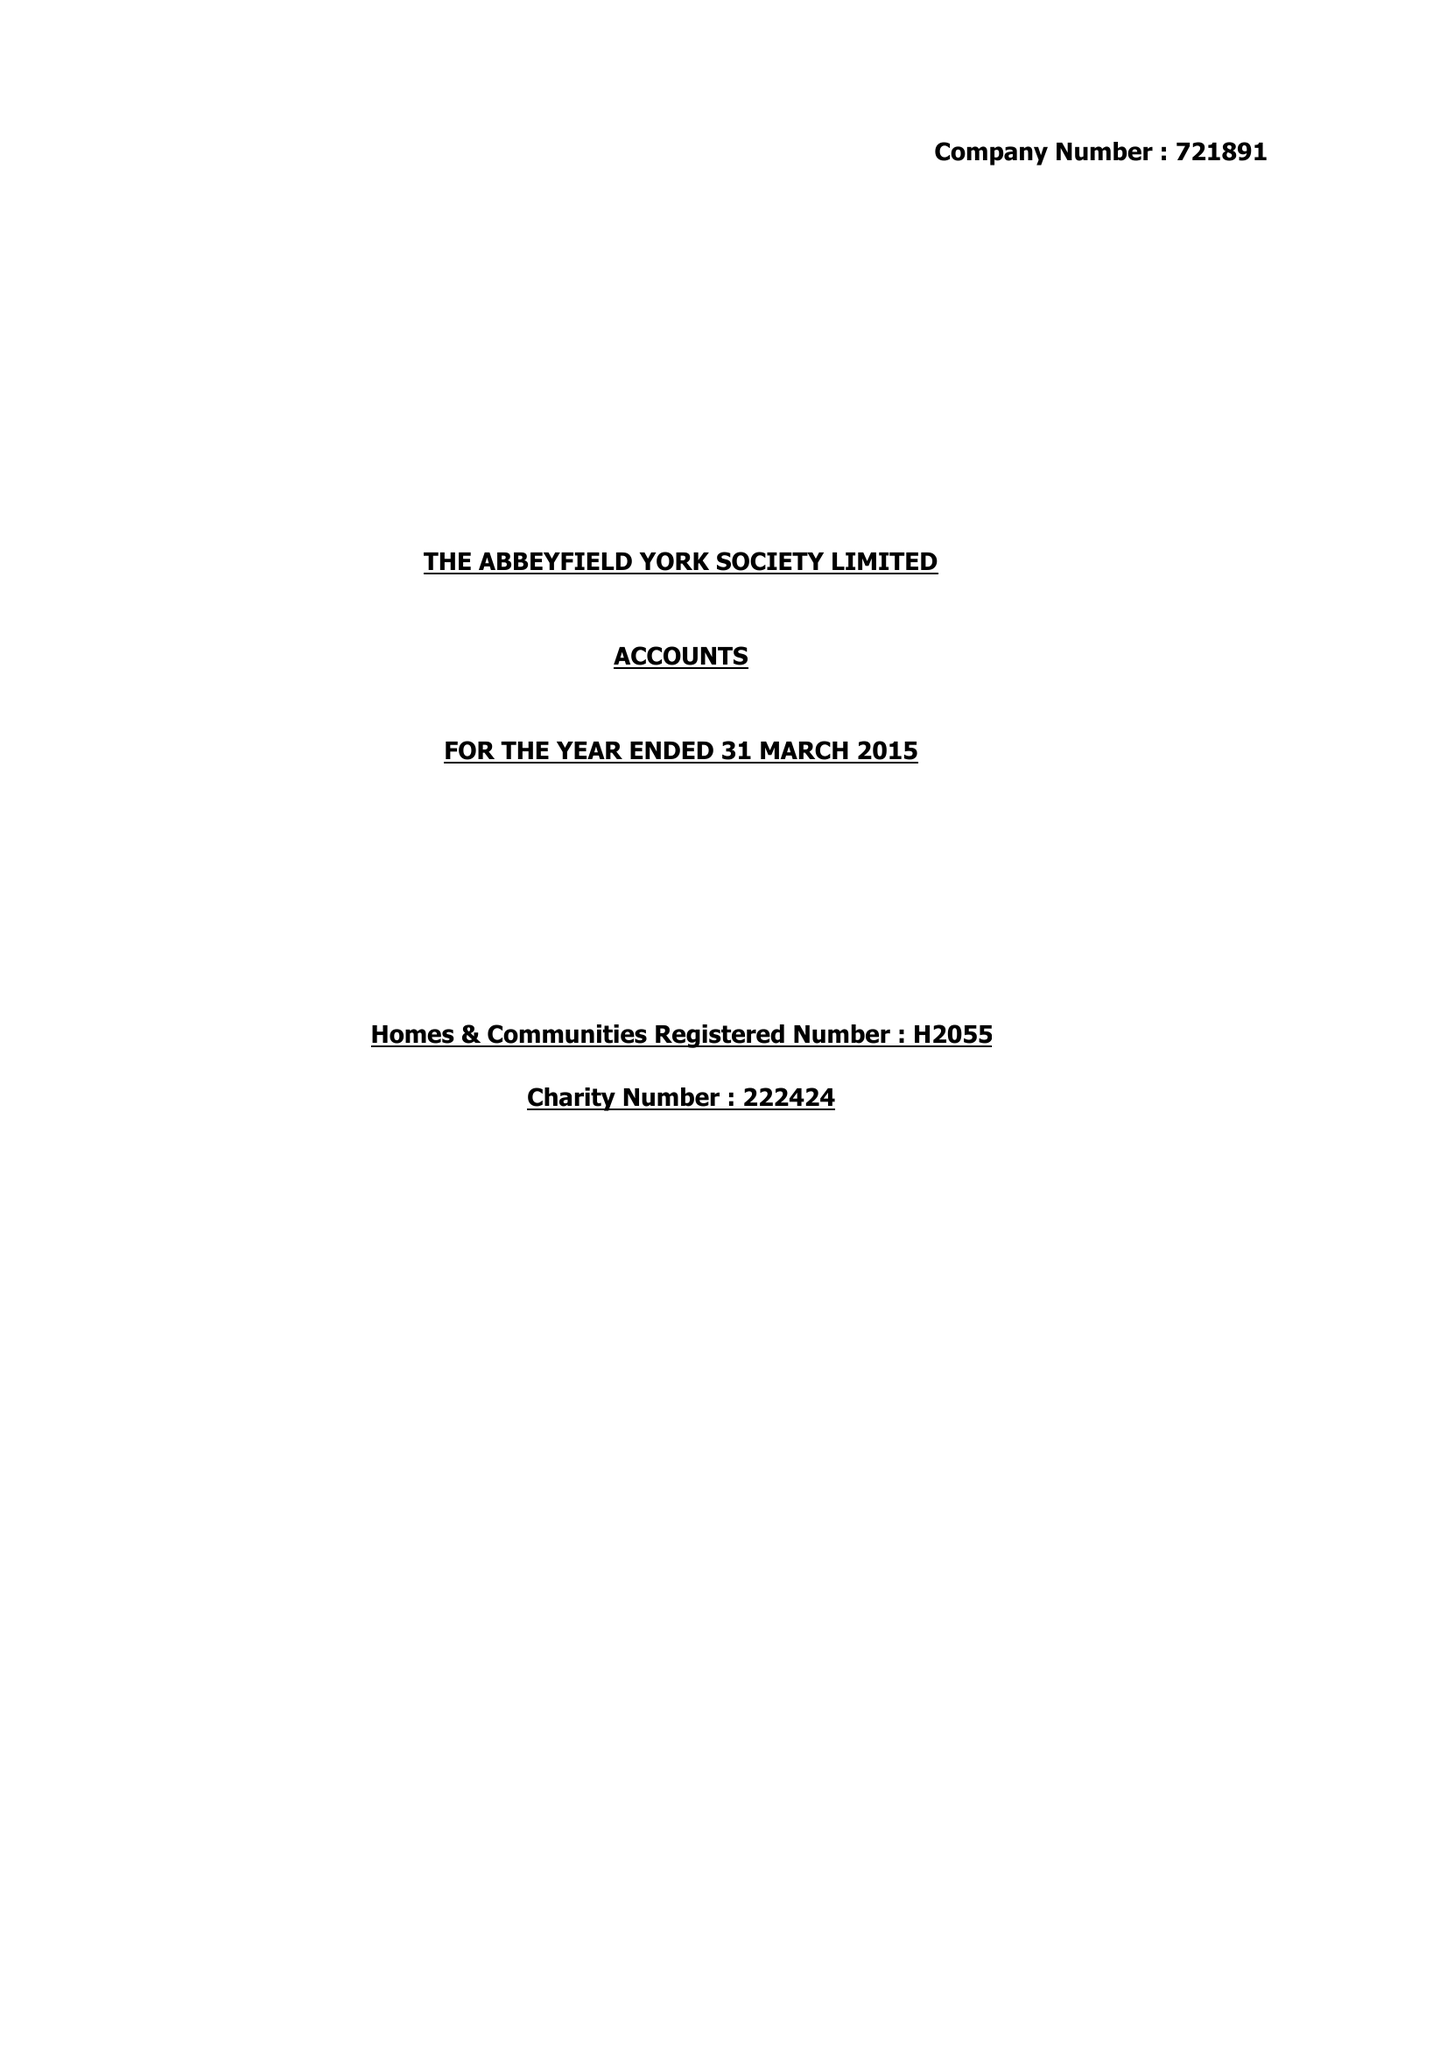What is the value for the report_date?
Answer the question using a single word or phrase. 2015-03-31 